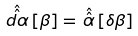<formula> <loc_0><loc_0><loc_500><loc_500>\hat { \hat { \, d \alpha \, } } [ \beta ] = \hat { \hat { \, \alpha \, } } [ \delta \beta ]</formula> 